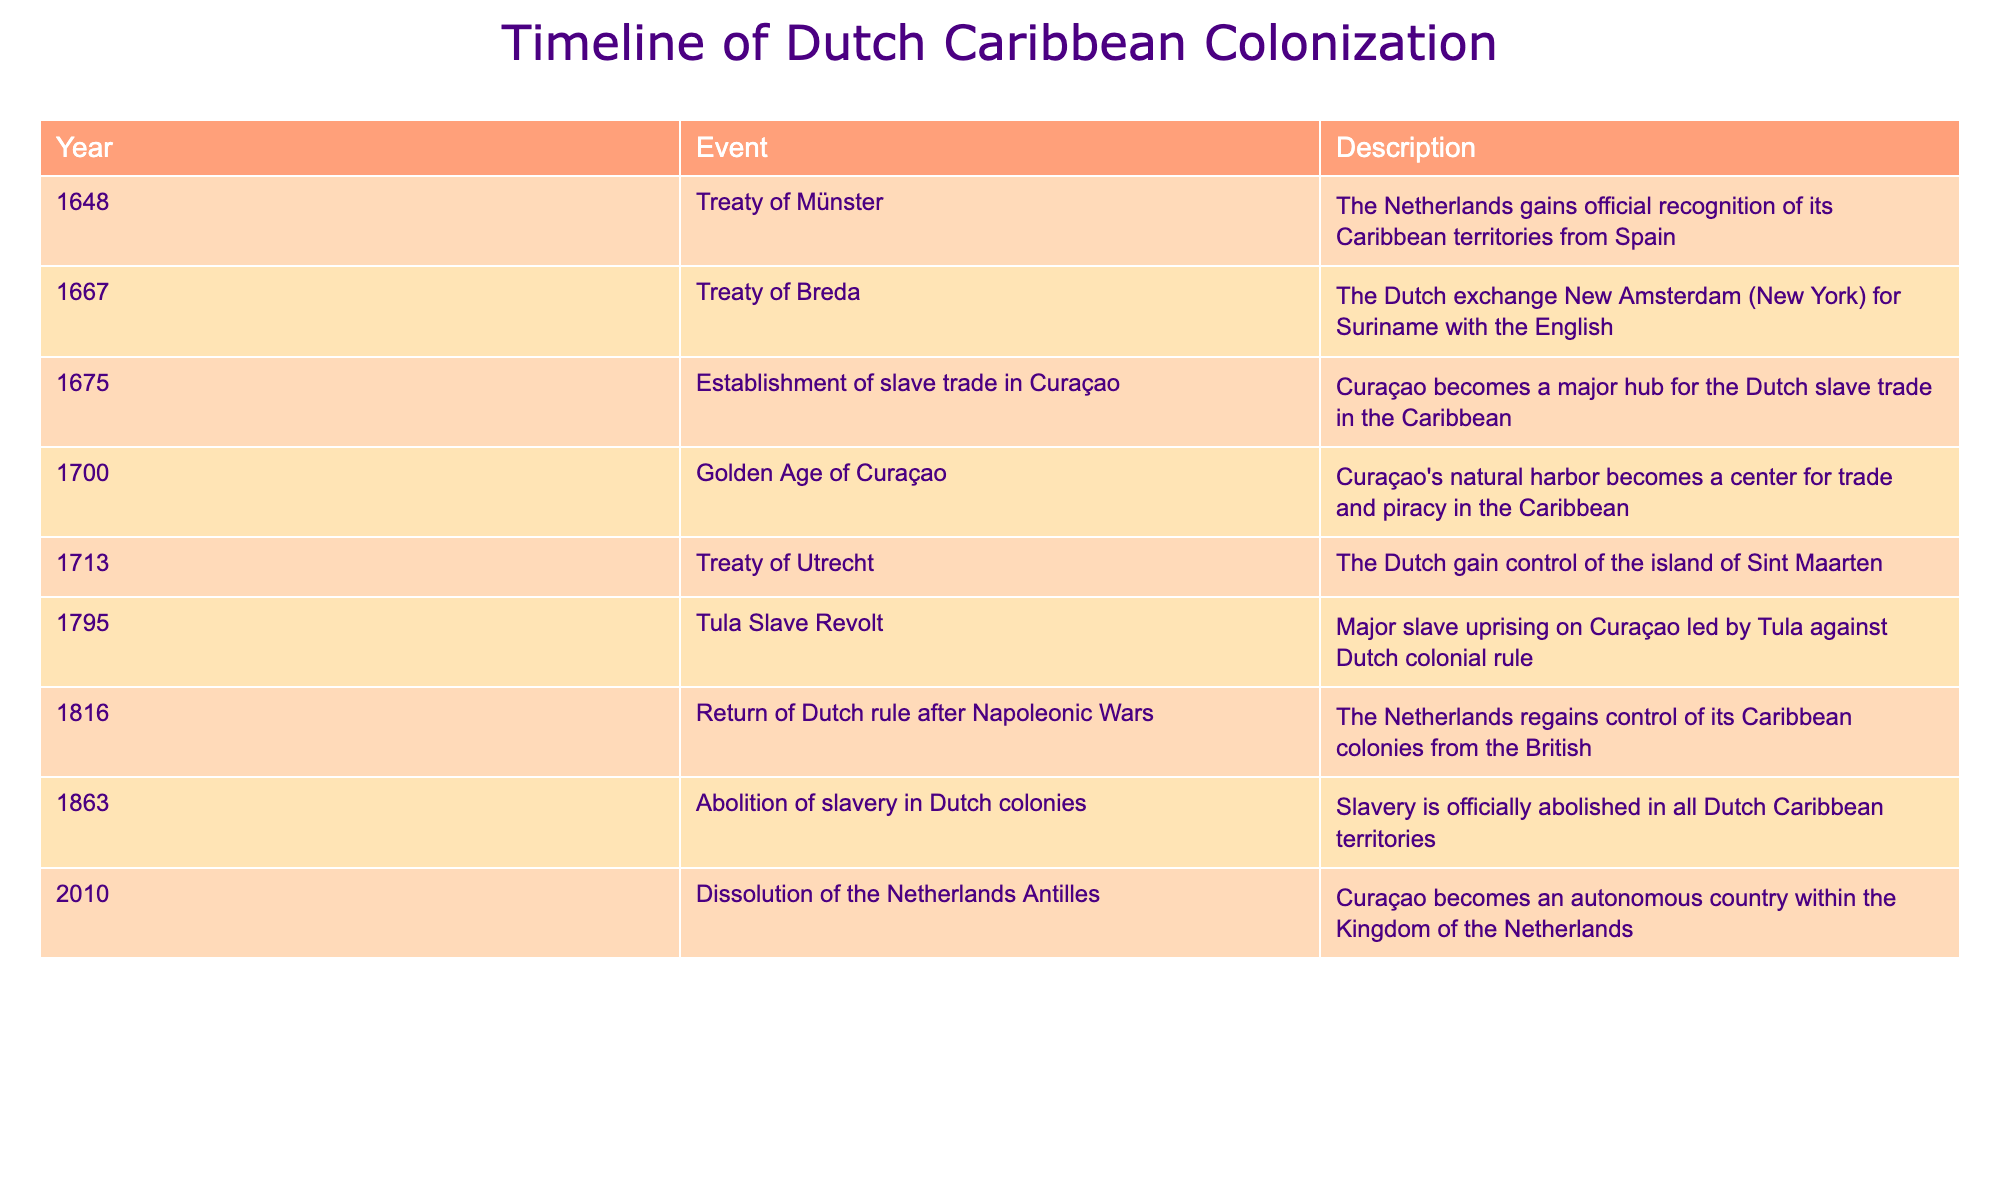What year was the Treaty of Utrecht signed? The table lists the Treaty of Utrecht under the Year column, which shows the year as 1713.
Answer: 1713 What major event happened in Curaçao in 1675? Referring to the table, it states that in 1675, the establishment of the slave trade in Curaçao occurred, making it a major hub for the Dutch slave trade in the Caribbean.
Answer: Establishment of slave trade in Curaçao How many years passed between the abolition of slavery and the dissolution of the Netherlands Antilles? The abolition of slavery occurred in 1863 and the dissolution of the Netherlands Antilles happened in 2010. Subtracting these years (2010 - 1863) gives a difference of 147 years.
Answer: 147 years Was the Tula Slave Revolt a significant uprising in Curaçao? The table records the Tula Slave Revolt as a major slave uprising in 1795, indicating its significance against Dutch colonial rule.
Answer: Yes Which event resulted in the Dutch gaining control of Sint Maarten? According to the timeline, the Treaty of Utrecht in 1713 resulted in the Dutch gaining control of Sint Maarten.
Answer: Treaty of Utrecht What is the sequence of events from the establishment of the slave trade in Curaçao to the abolition of slavery? The establishment of the slave trade in Curaçao occurred in 1675 and slavery was abolished in 1863. This shows a span of time where the slave trade was active before its eventual abolition, covering 88 years of continued slave practices.
Answer: 88 years Did the Treaty of Breda involve a land exchange with the English? The table states that in 1667, the Treaty of Breda involved the Dutch exchanging New Amsterdam (New York) for Suriname with the English, confirming that it was an exchange.
Answer: Yes What were the two key treaties that recognized Dutch territories in the Caribbean? The Treaty of Münster in 1648 recognized Dutch territories, and later the Treaty of Breda in 1667 included significant territorial exchanges, thus both treaties were key.
Answer: Treaty of Münster and Treaty of Breda 